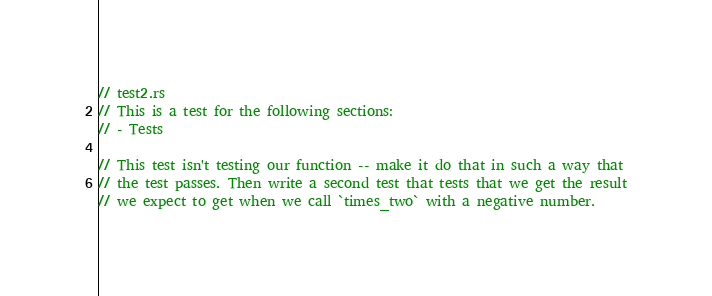Convert code to text. <code><loc_0><loc_0><loc_500><loc_500><_Rust_>// test2.rs
// This is a test for the following sections:
// - Tests

// This test isn't testing our function -- make it do that in such a way that
// the test passes. Then write a second test that tests that we get the result
// we expect to get when we call `times_two` with a negative number.</code> 